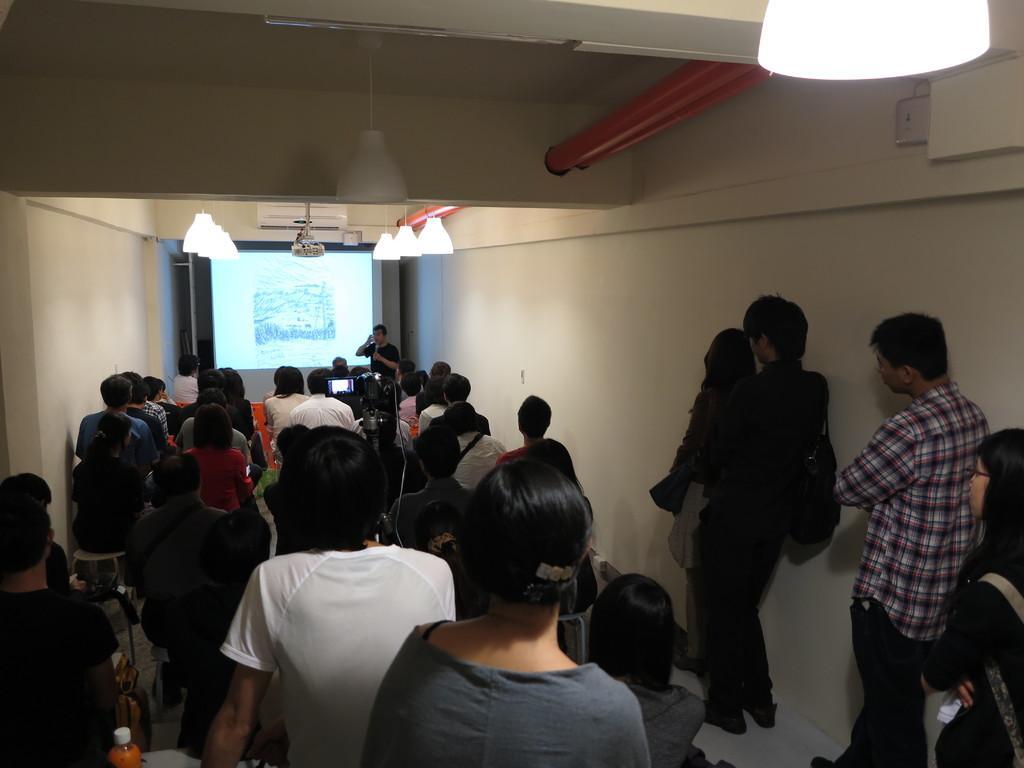How would you summarize this image in a sentence or two? In this image I can see there are many people are sitting one after the other and there is the screen in the middle and on the right side people are standing. 